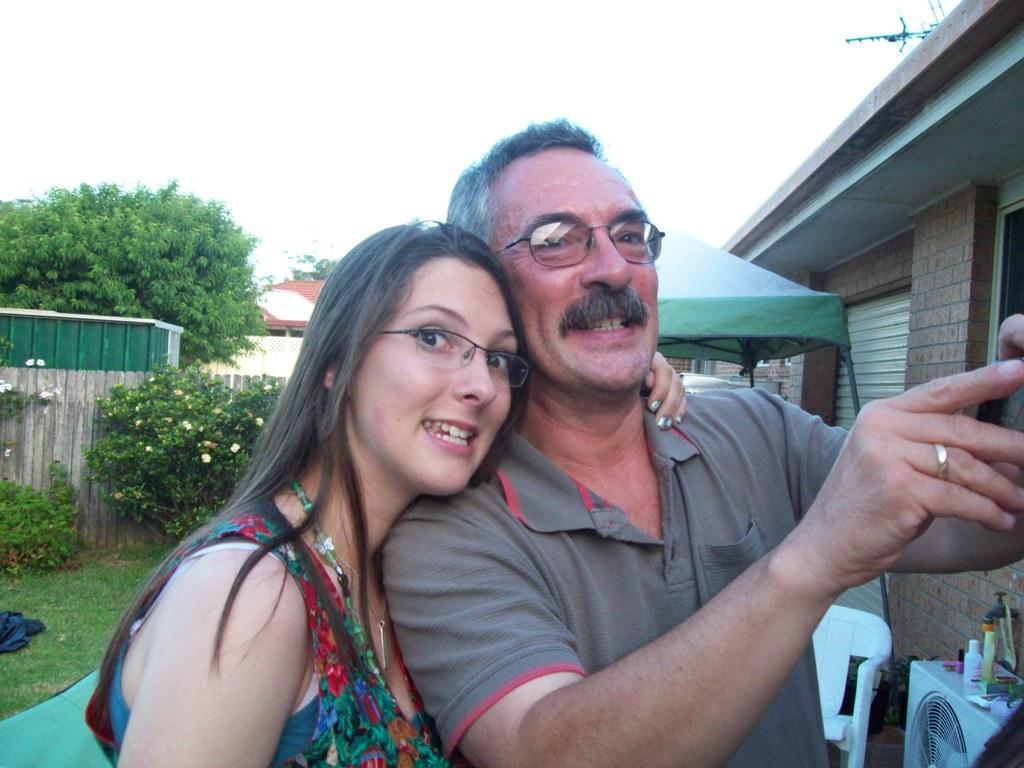Describe this image in one or two sentences. In this image there are two persons standing and smiling, there are some items on the air conditioner, there is a chair, there are houses, plants, trees, and in the background there is sky. 